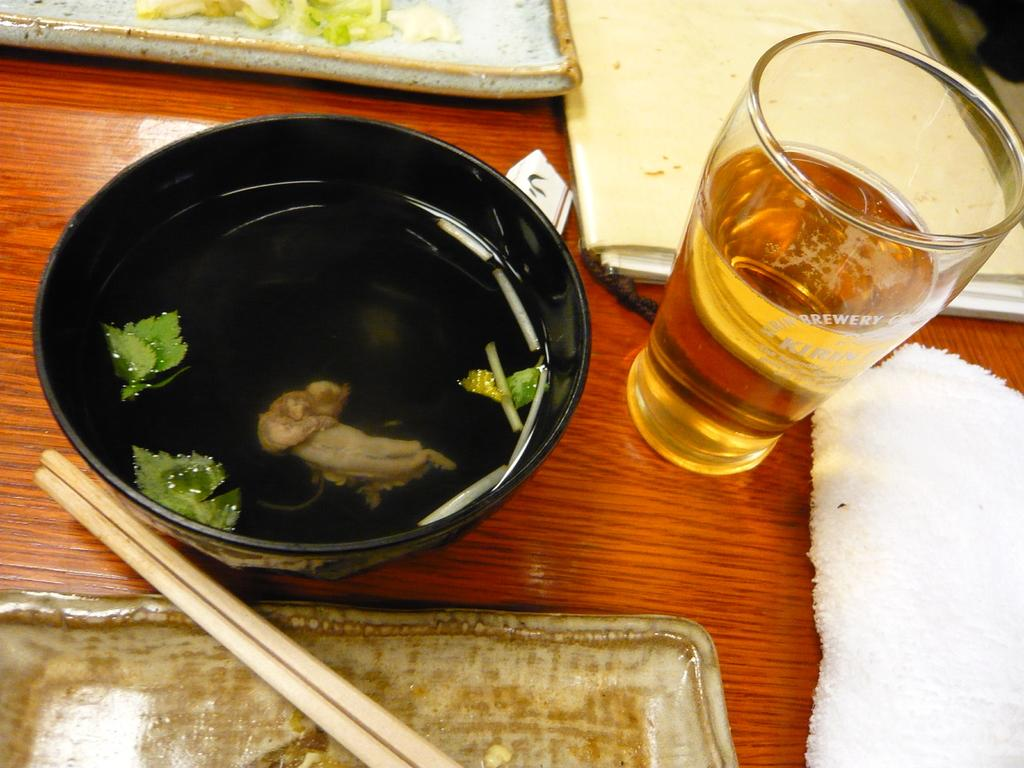What is on the table in the image? There is a bowl, a glass, and chopsticks on the table. What is inside the bowl? The facts do not specify what is inside the bowl. What is in the glass? There is a drink in the glass. Are there any other items on the table besides the bowl, glass, and chopsticks? Yes, there are other things on the table. What type of fear can be seen on the faces of the balls in the image? There are no balls present in the image, and therefore no fear can be observed on their faces. 